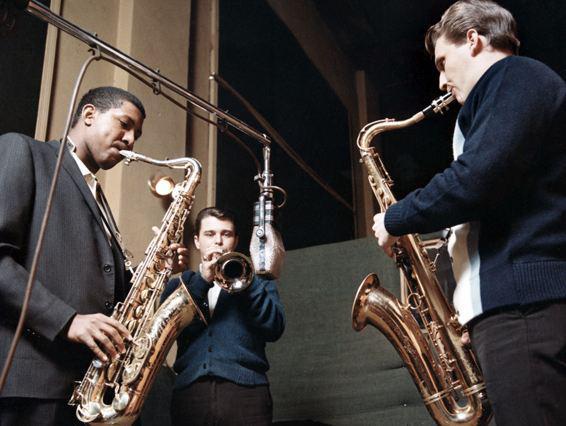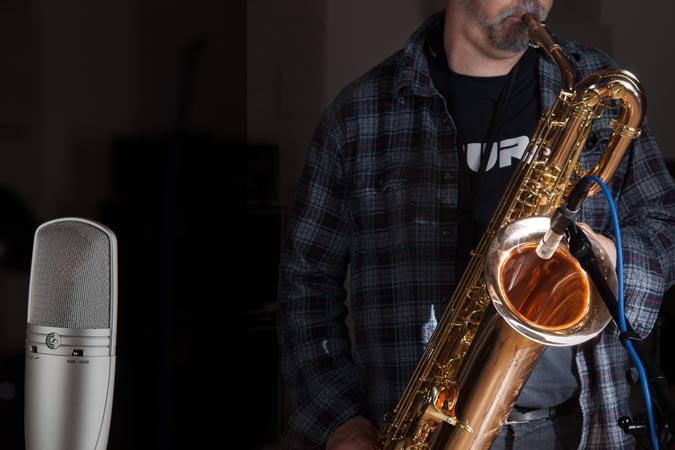The first image is the image on the left, the second image is the image on the right. For the images shown, is this caption "A man is blowing into the mouthpiece of the saxophone." true? Answer yes or no. Yes. The first image is the image on the left, the second image is the image on the right. Assess this claim about the two images: "At least one image includes a rightward turned man in dark clothing standing and playing a saxophone.". Correct or not? Answer yes or no. Yes. 